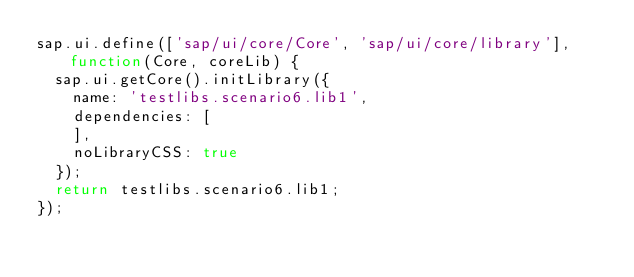Convert code to text. <code><loc_0><loc_0><loc_500><loc_500><_JavaScript_>sap.ui.define(['sap/ui/core/Core', 'sap/ui/core/library'], function(Core, coreLib) {
	sap.ui.getCore().initLibrary({
		name: 'testlibs.scenario6.lib1',
		dependencies: [
		],
		noLibraryCSS: true
	});
	return testlibs.scenario6.lib1;
});</code> 